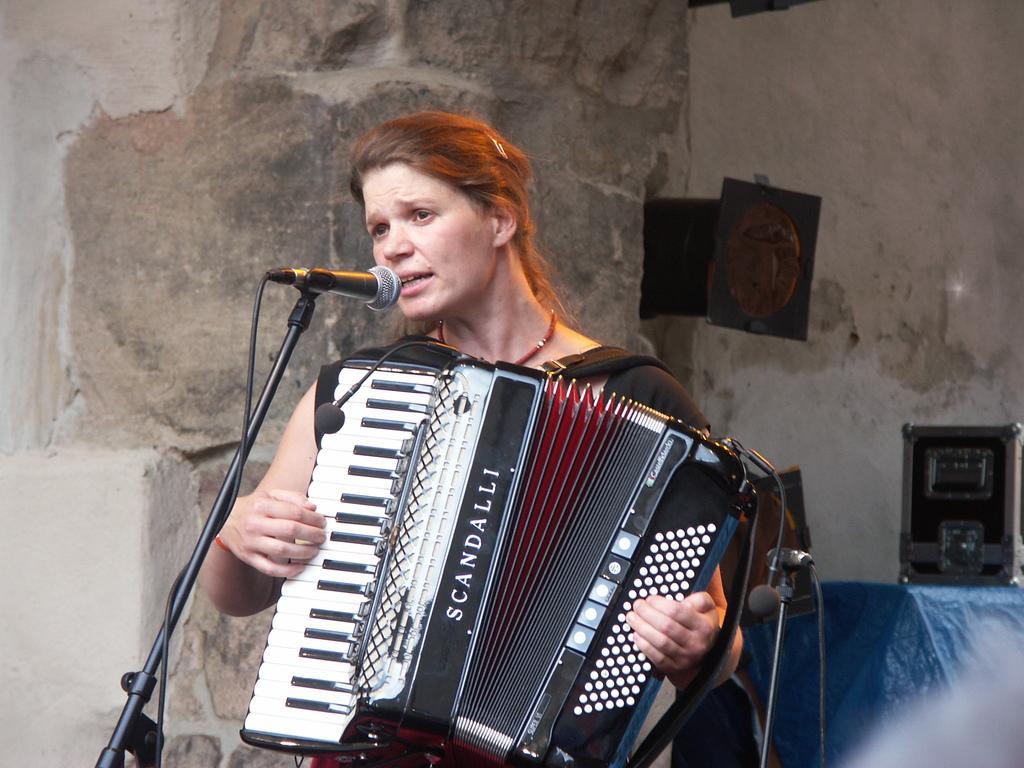In one or two sentences, can you explain what this image depicts? In the center of the image a lady is standing and holding a garmin and playing and singing. On the left side of the image we can see a mic with stand. In the background of the image we can see some musical instruments, cloth, wall, boards. 